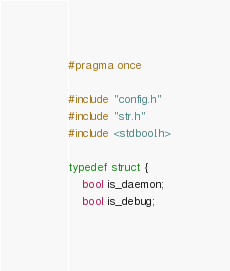<code> <loc_0><loc_0><loc_500><loc_500><_C_>#pragma once

#include "config.h"
#include "str.h"
#include <stdbool.h>

typedef struct {
    bool is_daemon;
    bool is_debug;</code> 